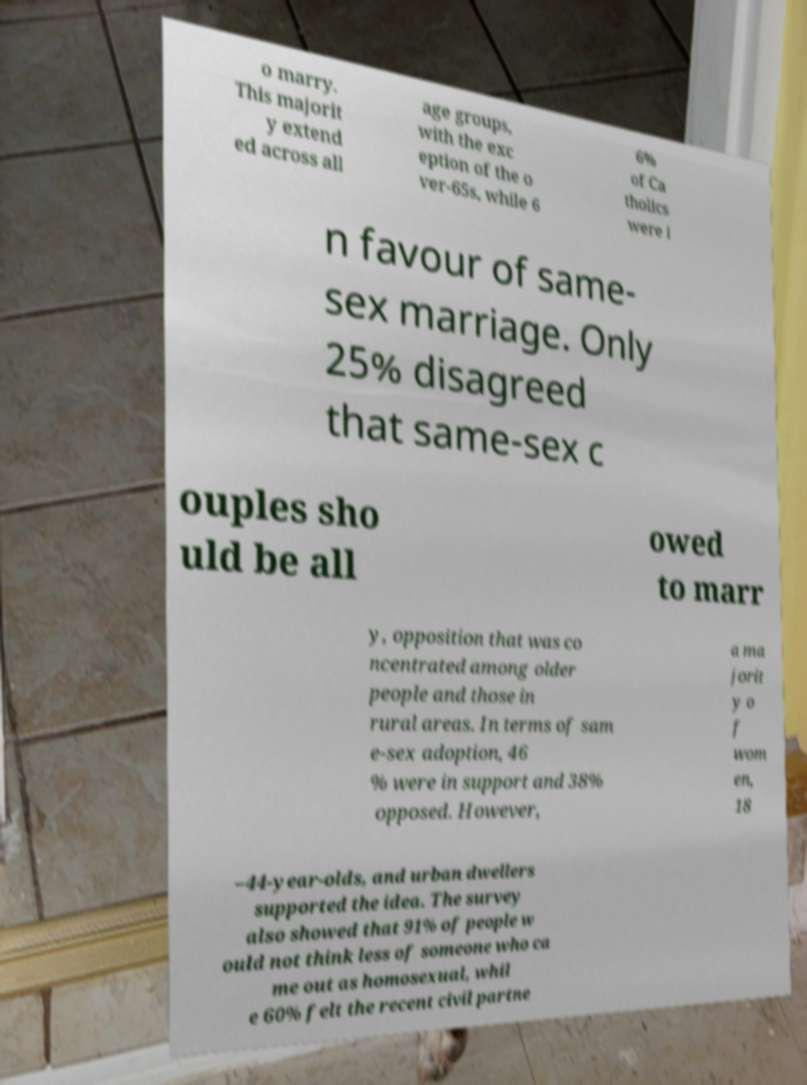There's text embedded in this image that I need extracted. Can you transcribe it verbatim? o marry. This majorit y extend ed across all age groups, with the exc eption of the o ver-65s, while 6 6% of Ca tholics were i n favour of same- sex marriage. Only 25% disagreed that same-sex c ouples sho uld be all owed to marr y, opposition that was co ncentrated among older people and those in rural areas. In terms of sam e-sex adoption, 46 % were in support and 38% opposed. However, a ma jorit y o f wom en, 18 –44-year-olds, and urban dwellers supported the idea. The survey also showed that 91% of people w ould not think less of someone who ca me out as homosexual, whil e 60% felt the recent civil partne 